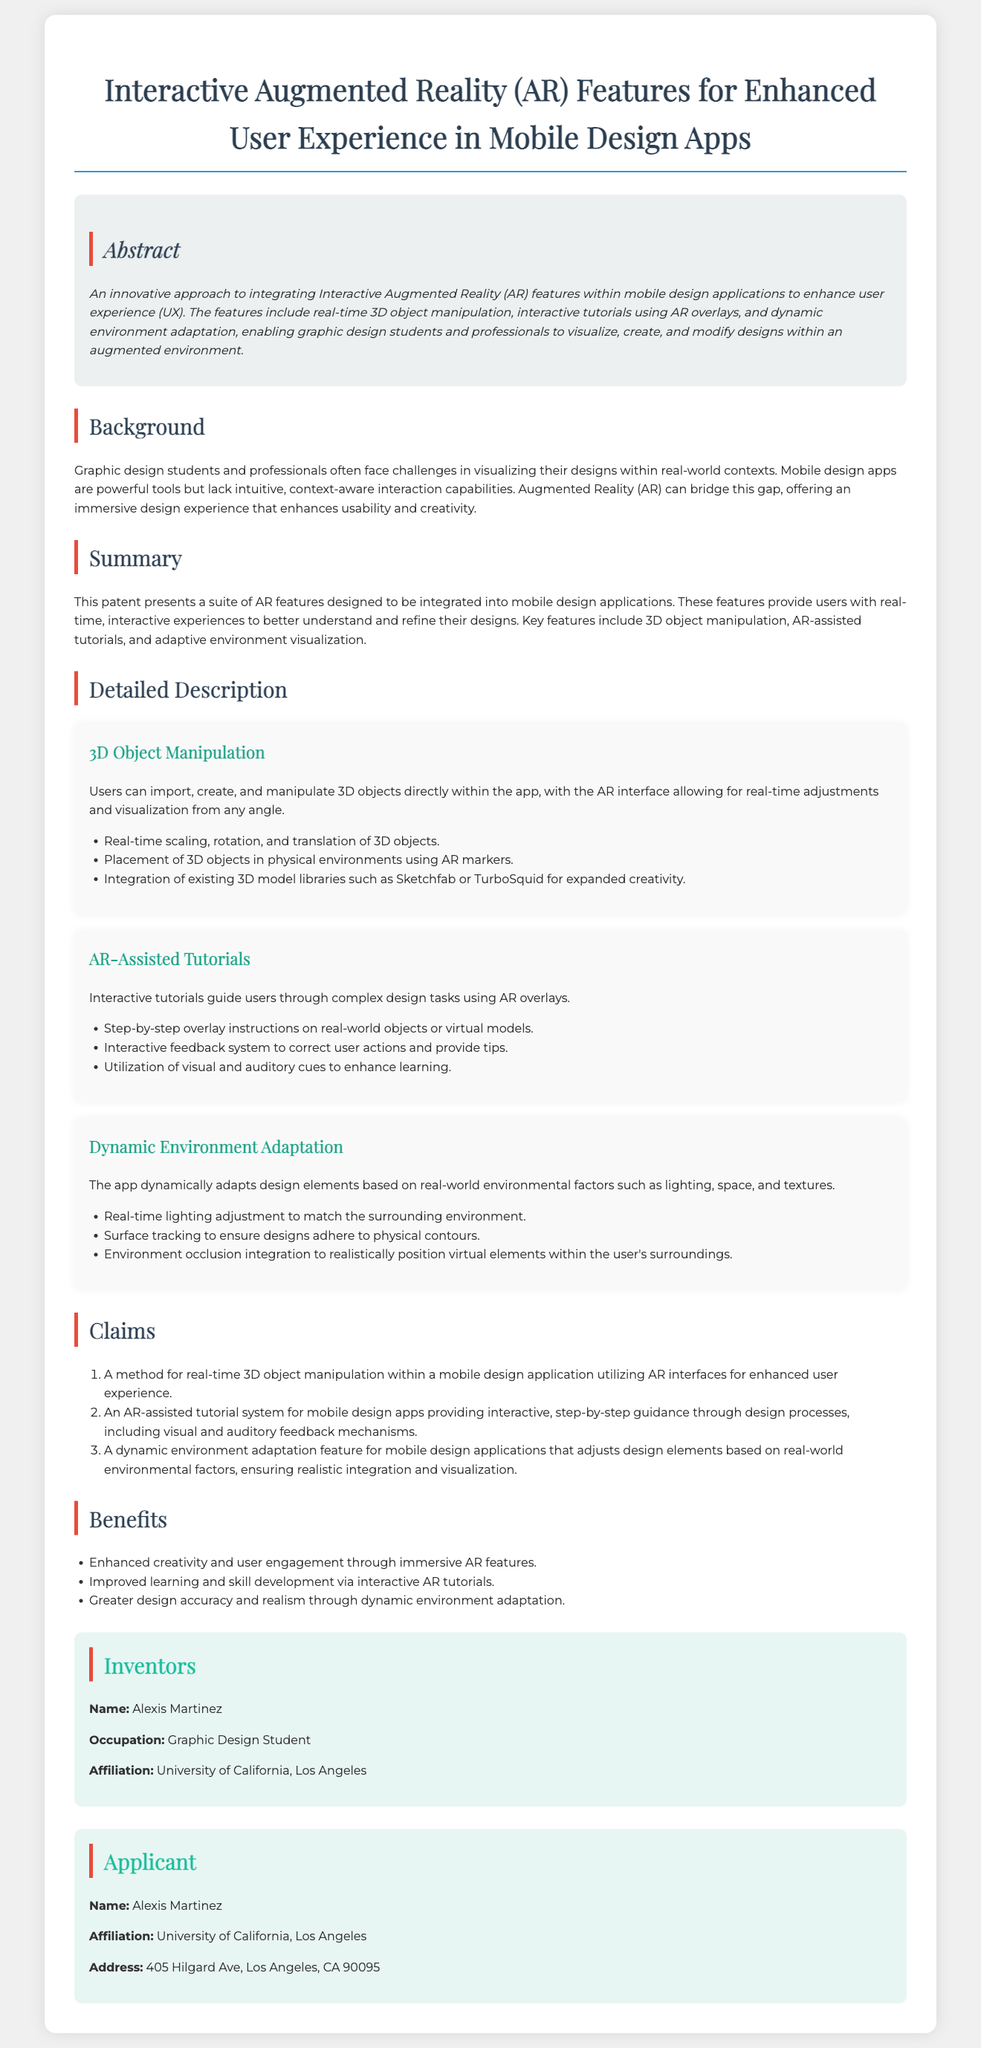What is the title of the patent? The title is presented clearly at the top of the document, summarizing the main focus of the patent.
Answer: Interactive Augmented Reality (AR) Features for Enhanced User Experience in Mobile Design Apps Who is the inventor? The inventor's name is listed in the designated section for inventors in the document.
Answer: Alexis Martinez What university is the inventor affiliated with? The affiliation of the inventor provides information about their educational background.
Answer: University of California, Los Angeles What is one of the key features discussed in the patent? The document outlines several features that enhance user experience, detailed under specific sections.
Answer: 3D Object Manipulation How many claims are included in the document? The number of claims is indicated in the claims section of the patent.
Answer: 3 What does the "Dynamic Environment Adaptation" feature do? This feature is described in detail to illustrate how it interacts with the user's surroundings.
Answer: Adjusts design elements based on real-world environmental factors What is one benefit of using AR features in mobile design apps? Benefits are outlined in a list format, emphasizing their advantages for users.
Answer: Enhanced creativity and user engagement What type of feedback system is included in the AR-Assisted Tutorials? The type of feedback provided helps understand the tutorial's functionality.
Answer: Interactive feedback system 